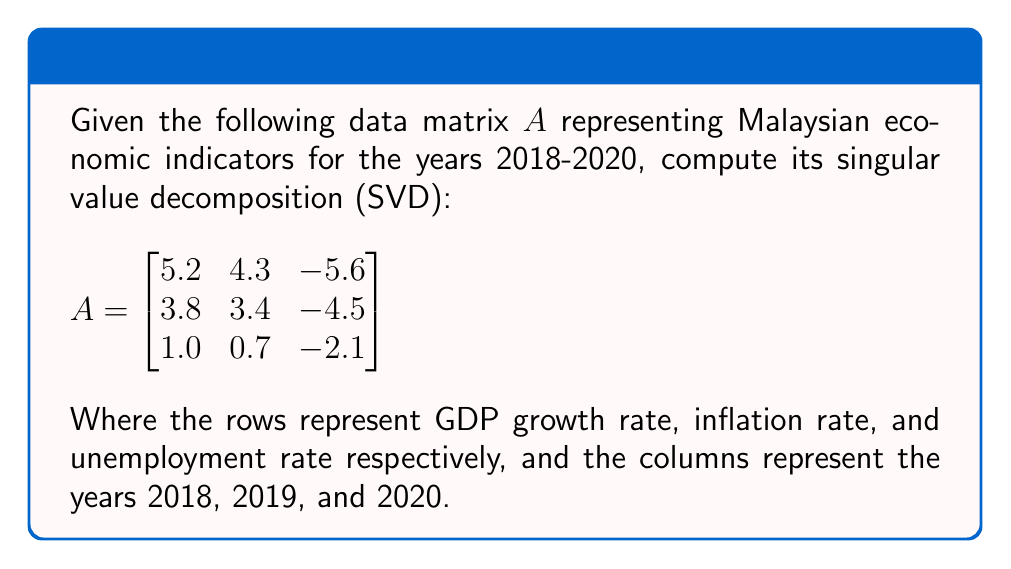Provide a solution to this math problem. To compute the singular value decomposition of matrix $A$, we need to find matrices $U$, $\Sigma$, and $V^T$ such that $A = U\Sigma V^T$.

Step 1: Calculate $A^TA$ and $AA^T$
$$A^TA = \begin{bmatrix}
41.28 & 33.61 & -51.94 \\
33.61 & 27.74 & -42.56 \\
-51.94 & -42.56 & 65.78
\end{bmatrix}$$

$$AA^T = \begin{bmatrix}
66.73 & 53.24 & 18.76 \\
53.24 & 42.50 & 14.97 \\
18.76 & 14.97 & 5.30
\end{bmatrix}$$

Step 2: Find eigenvalues of $A^TA$ (which are the same as the squares of singular values)
The characteristic equation is:
$$(41.28 - \lambda)(27.74 - \lambda)(65.78 - \lambda) - (33.61)^2(65.78 - \lambda) - (-51.94)^2(27.74 - \lambda) = 0$$

Solving this equation yields eigenvalues:
$\lambda_1 \approx 134.54$, $\lambda_2 \approx 0.26$, $\lambda_3 \approx 0$

Step 3: Calculate singular values
$\sigma_1 = \sqrt{134.54} \approx 11.60$
$\sigma_2 = \sqrt{0.26} \approx 0.51$
$\sigma_3 = 0$

Step 4: Find eigenvectors of $A^TA$ to form columns of $V$
For $\lambda_1 = 134.54$: $v_1 \approx [-0.59, -0.48, 0.65]^T$
For $\lambda_2 = 0.26$: $v_2 \approx [-0.56, 0.82, -0.11]^T$
For $\lambda_3 = 0$: $v_3 \approx [0.58, 0.31, 0.75]^T$

Step 5: Calculate $U$ columns using $u_i = \frac{1}{\sigma_i}Av_i$ for non-zero singular values
$u_1 \approx [-0.82, -0.65, -0.22]^T$
$u_2 \approx [0.02, -0.53, 0.85]^T$
$u_3 \approx [0.57, -0.55, -0.61]^T$ (from null space of $A^T$)

Step 6: Form matrices $U$, $\Sigma$, and $V^T$

$$U \approx \begin{bmatrix}
-0.82 & 0.02 & 0.57 \\
-0.65 & -0.53 & -0.55 \\
-0.22 & 0.85 & -0.61
\end{bmatrix}$$

$$\Sigma \approx \begin{bmatrix}
11.60 & 0 & 0 \\
0 & 0.51 & 0 \\
0 & 0 & 0
\end{bmatrix}$$

$$V^T \approx \begin{bmatrix}
-0.59 & -0.48 & 0.65 \\
-0.56 & 0.82 & -0.11 \\
0.58 & 0.31 & 0.75
\end{bmatrix}$$
Answer: $A \approx U\Sigma V^T$, where:
$$U \approx \begin{bmatrix}
-0.82 & 0.02 & 0.57 \\
-0.65 & -0.53 & -0.55 \\
-0.22 & 0.85 & -0.61
\end{bmatrix}$$
$$\Sigma \approx \begin{bmatrix}
11.60 & 0 & 0 \\
0 & 0.51 & 0 \\
0 & 0 & 0
\end{bmatrix}$$
$$V^T \approx \begin{bmatrix}
-0.59 & -0.48 & 0.65 \\
-0.56 & 0.82 & -0.11 \\
0.58 & 0.31 & 0.75
\end{bmatrix}$$ 